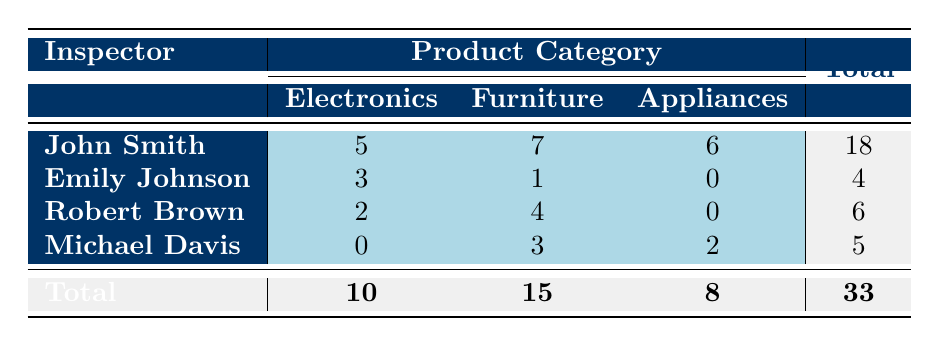What is the total number of quality control failures by John Smith? The table shows that John Smith has 5 failures in Electronics, 7 in Furniture, and 6 in Appliances. To find the total, we sum these values: 5 + 7 + 6 = 18.
Answer: 18 How many quality control failures were recorded for the product category Appliances? From the totals in the last row, the table indicates that there are a total of 8 failures in the Appliances category.
Answer: 8 Which inspector has the highest number of total quality control failures? By examining the total failures in the last column, John Smith has a total of 18 failures, which is the highest compared to other inspectors.
Answer: John Smith Is it true that Robert Brown has more failures in Furniture than in Electronics? The table shows Robert Brown has 4 failures in Furniture and 2 in Electronics. Since 4 is greater than 2, the statement is true.
Answer: Yes What is the average number of quality control failures by Emily Johnson across all product categories? Emily Johnson has 3 failures in Electronics, 1 in Furniture, and 0 in Appliances. The total is 3 + 1 + 0 = 4, with 3 entries, so the average is 4 / 3 ≈ 1.33.
Answer: 1.33 What is the difference in total quality control failures between John Smith and Emily Johnson? John Smith has a total of 18 failures while Emily Johnson has 4. To find the difference, we subtract 4 from 18: 18 - 4 = 14.
Answer: 14 How many inspectors reported zero failures in any product category? Looking at the table, only Emily Johnson has zero failures in Appliances, and Michael Davis has zero failures in Electronics. Therefore, two inspectors reported zero failures in their respective categories.
Answer: 2 For which product category did Robert Brown have the least number of failures? In the table, Robert Brown has 2 failures in Electronics, 4 in Furniture, and 0 in Appliances. The least number of failures is in Appliances, where he had none.
Answer: Appliances 